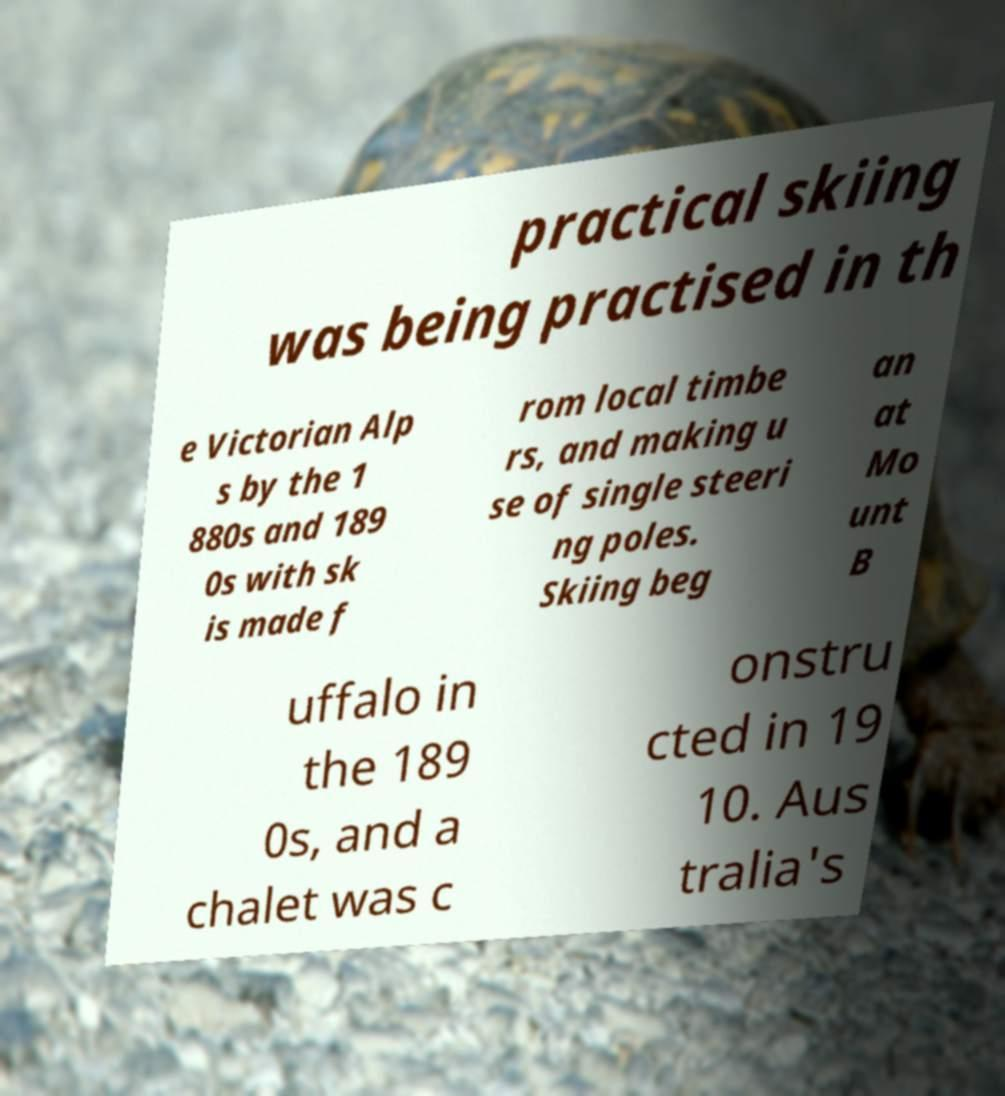I need the written content from this picture converted into text. Can you do that? practical skiing was being practised in th e Victorian Alp s by the 1 880s and 189 0s with sk is made f rom local timbe rs, and making u se of single steeri ng poles. Skiing beg an at Mo unt B uffalo in the 189 0s, and a chalet was c onstru cted in 19 10. Aus tralia's 